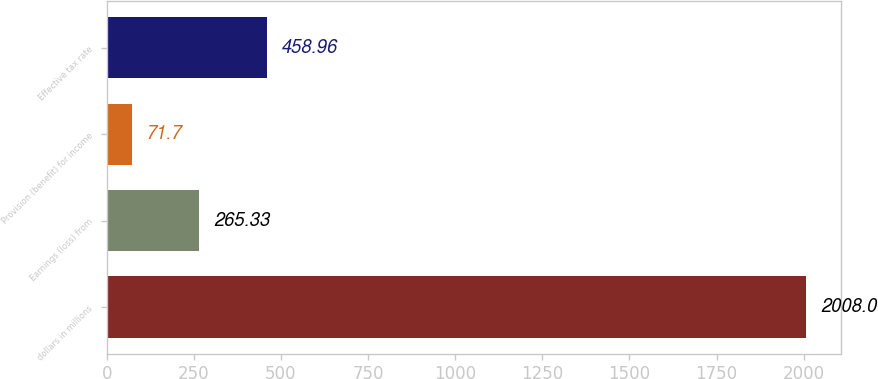<chart> <loc_0><loc_0><loc_500><loc_500><bar_chart><fcel>dollars in millions<fcel>Earnings (loss) from<fcel>Provision (benefit) for income<fcel>Effective tax rate<nl><fcel>2008<fcel>265.33<fcel>71.7<fcel>458.96<nl></chart> 